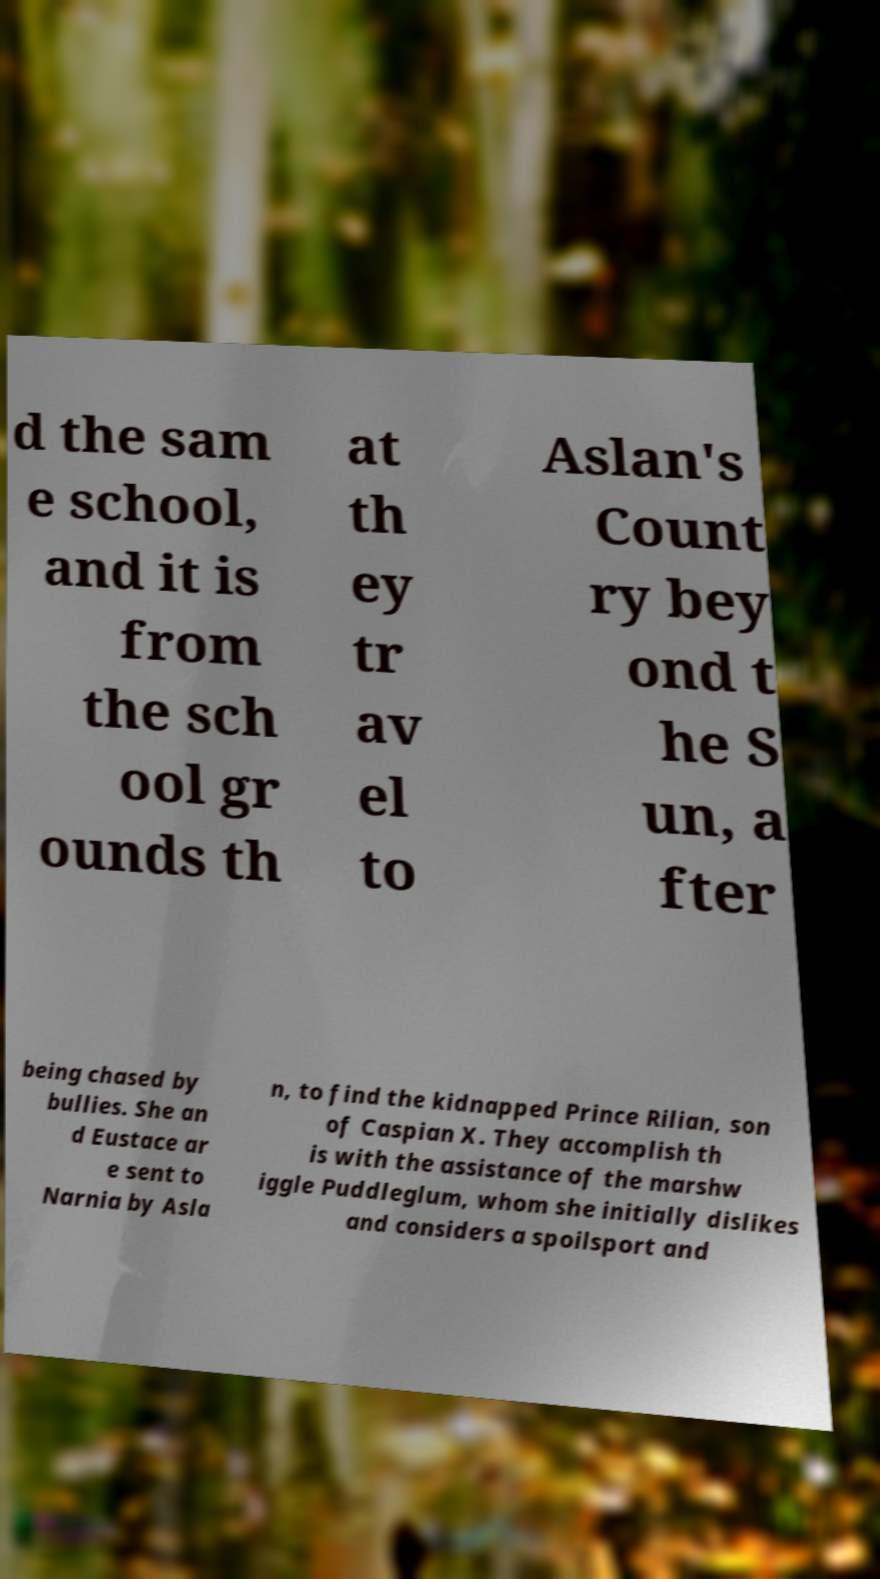Please read and relay the text visible in this image. What does it say? d the sam e school, and it is from the sch ool gr ounds th at th ey tr av el to Aslan's Count ry bey ond t he S un, a fter being chased by bullies. She an d Eustace ar e sent to Narnia by Asla n, to find the kidnapped Prince Rilian, son of Caspian X. They accomplish th is with the assistance of the marshw iggle Puddleglum, whom she initially dislikes and considers a spoilsport and 